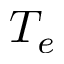Convert formula to latex. <formula><loc_0><loc_0><loc_500><loc_500>T _ { e }</formula> 